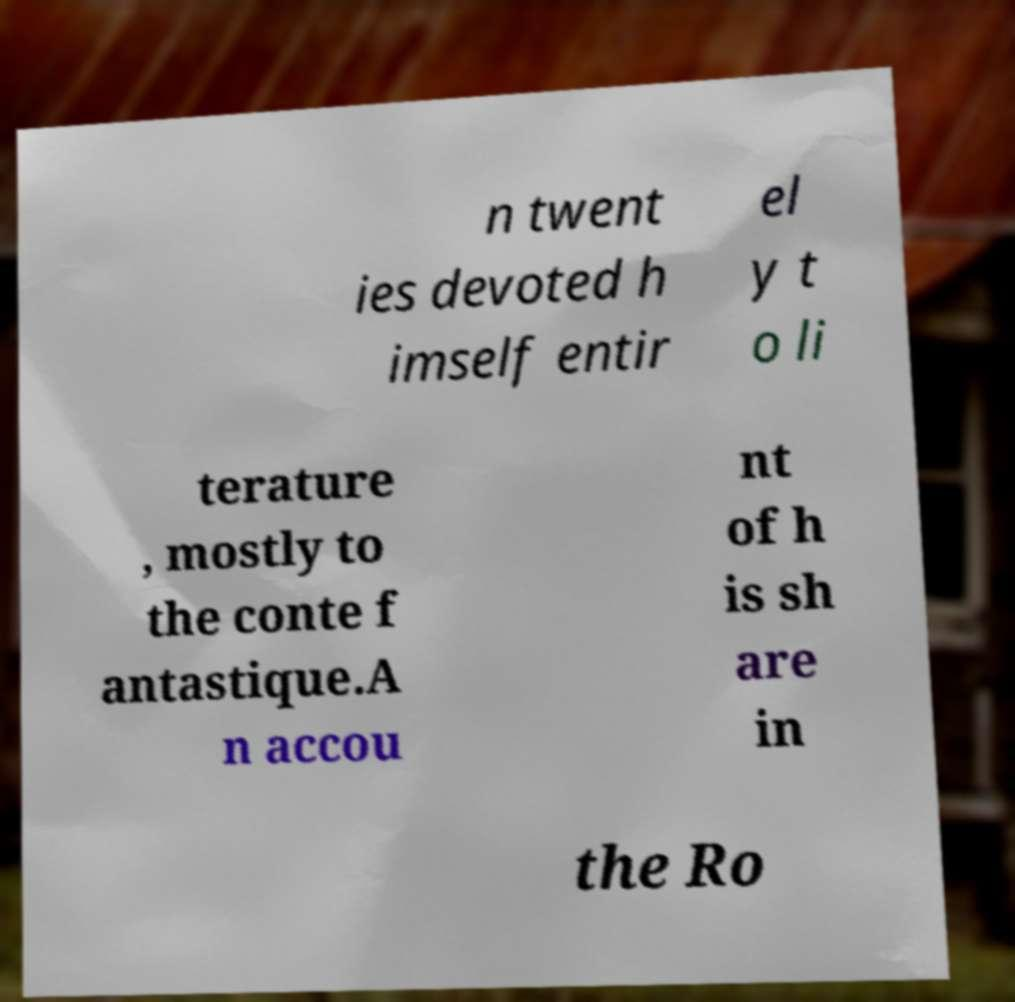Could you extract and type out the text from this image? n twent ies devoted h imself entir el y t o li terature , mostly to the conte f antastique.A n accou nt of h is sh are in the Ro 